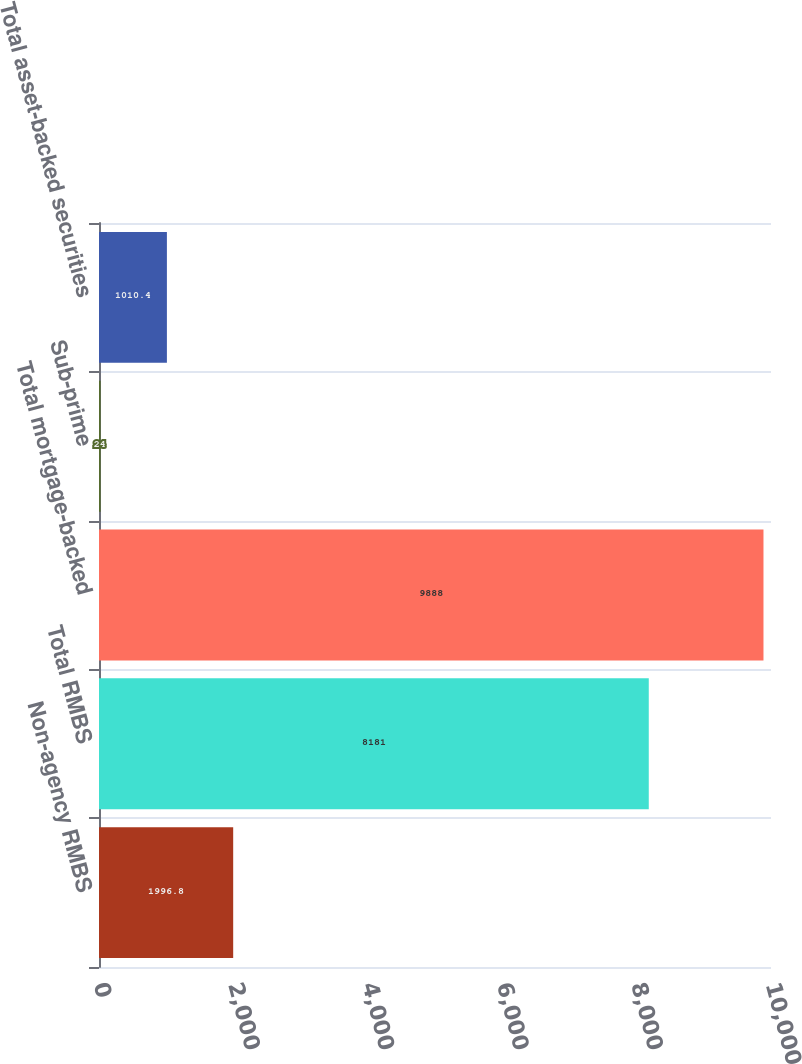Convert chart to OTSL. <chart><loc_0><loc_0><loc_500><loc_500><bar_chart><fcel>Non-agency RMBS<fcel>Total RMBS<fcel>Total mortgage-backed<fcel>Sub-prime<fcel>Total asset-backed securities<nl><fcel>1996.8<fcel>8181<fcel>9888<fcel>24<fcel>1010.4<nl></chart> 